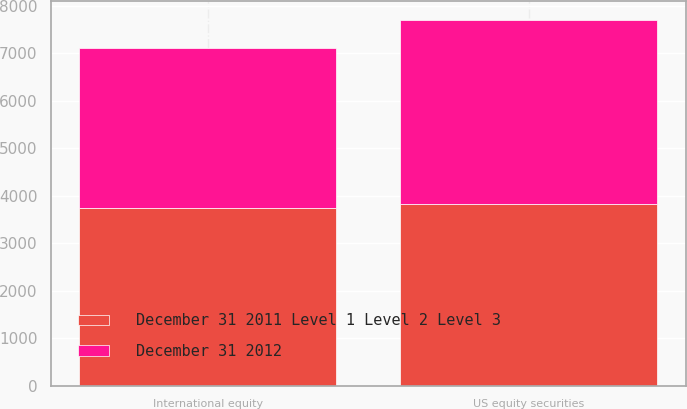<chart> <loc_0><loc_0><loc_500><loc_500><stacked_bar_chart><ecel><fcel>US equity securities<fcel>International equity<nl><fcel>December 31 2012<fcel>3871<fcel>3363<nl><fcel>December 31 2011 Level 1 Level 2 Level 3<fcel>3834<fcel>3750<nl></chart> 